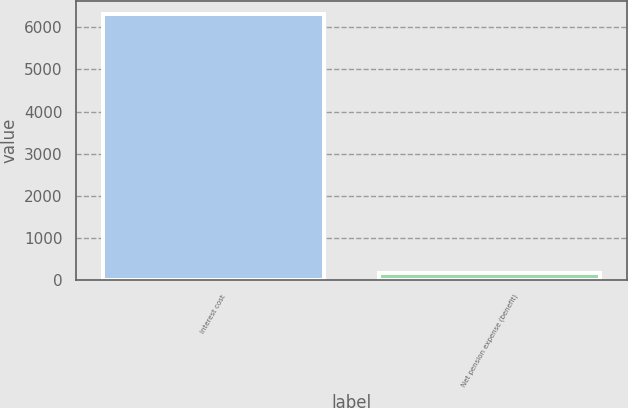Convert chart. <chart><loc_0><loc_0><loc_500><loc_500><bar_chart><fcel>Interest cost<fcel>Net pension expense (benefit)<nl><fcel>6315<fcel>172<nl></chart> 